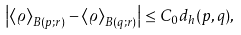Convert formula to latex. <formula><loc_0><loc_0><loc_500><loc_500>\left | \left \langle \varrho \right \rangle _ { B ( p ; r ) } - \left \langle \varrho \right \rangle _ { B ( q ; r ) } \right | \leq C _ { 0 } d _ { h } ( p , q ) ,</formula> 